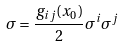<formula> <loc_0><loc_0><loc_500><loc_500>\sigma = \frac { g _ { i j } ( x _ { 0 } ) } { 2 } { \sigma ^ { i } } { \sigma ^ { j } }</formula> 